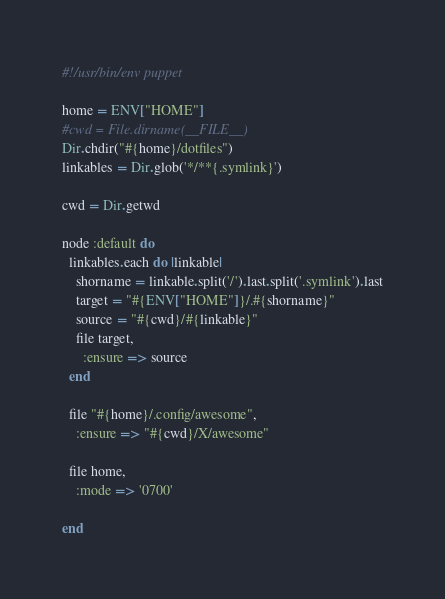<code> <loc_0><loc_0><loc_500><loc_500><_Ruby_>#!/usr/bin/env puppet

home = ENV["HOME"]
#cwd = File.dirname(__FILE__)
Dir.chdir("#{home}/dotfiles")
linkables = Dir.glob('*/**{.symlink}')

cwd = Dir.getwd

node :default do
  linkables.each do |linkable|
    shorname = linkable.split('/').last.split('.symlink').last
    target = "#{ENV["HOME"]}/.#{shorname}"
    source = "#{cwd}/#{linkable}"
    file target,
      :ensure => source
  end

  file "#{home}/.config/awesome",
    :ensure => "#{cwd}/X/awesome"

  file home,
    :mode => '0700'

end

</code> 